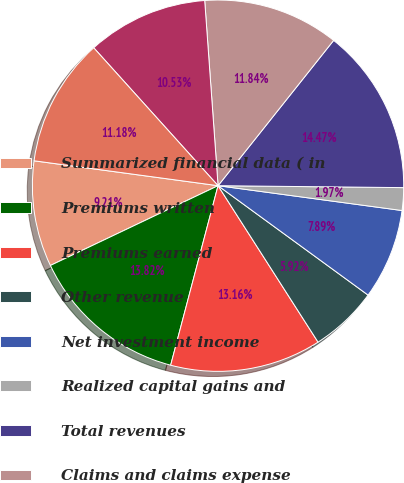Convert chart to OTSL. <chart><loc_0><loc_0><loc_500><loc_500><pie_chart><fcel>Summarized financial data ( in<fcel>Premiums written<fcel>Premiums earned<fcel>Other revenue<fcel>Net investment income<fcel>Realized capital gains and<fcel>Total revenues<fcel>Claims and claims expense<fcel>Amortization of DAC<fcel>Operating costs and expenses<nl><fcel>9.21%<fcel>13.82%<fcel>13.16%<fcel>5.92%<fcel>7.89%<fcel>1.97%<fcel>14.47%<fcel>11.84%<fcel>10.53%<fcel>11.18%<nl></chart> 